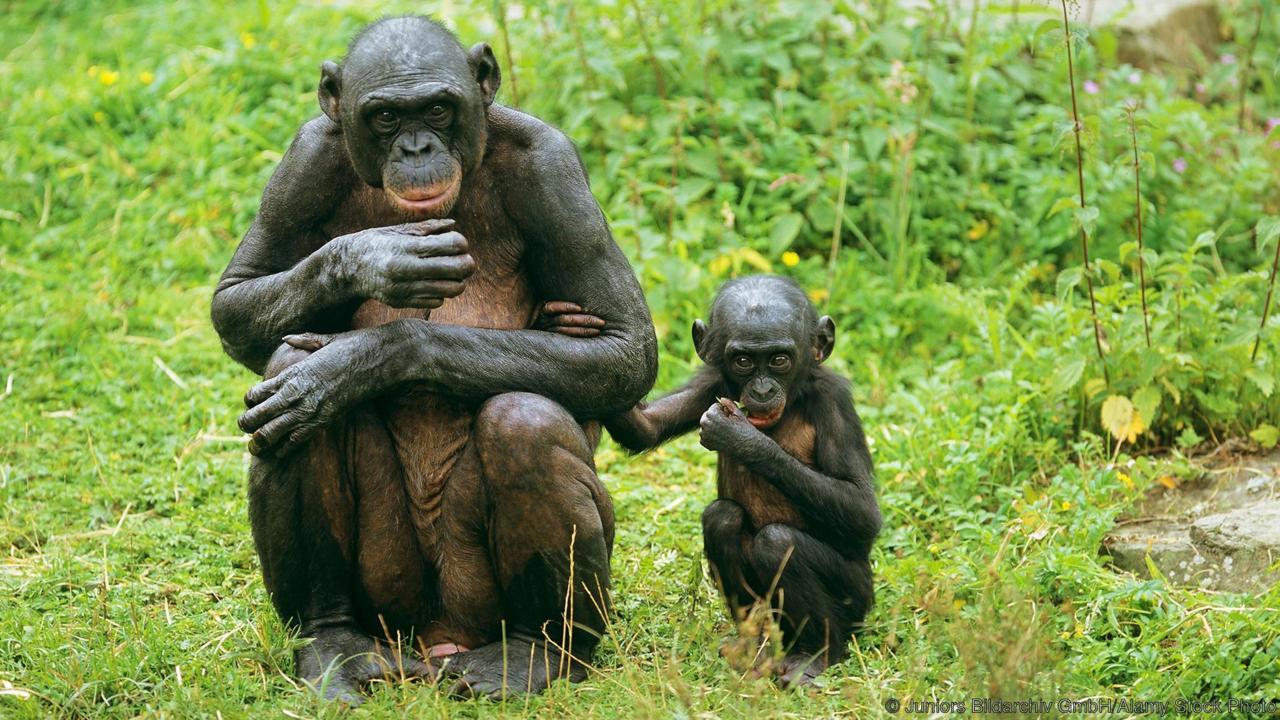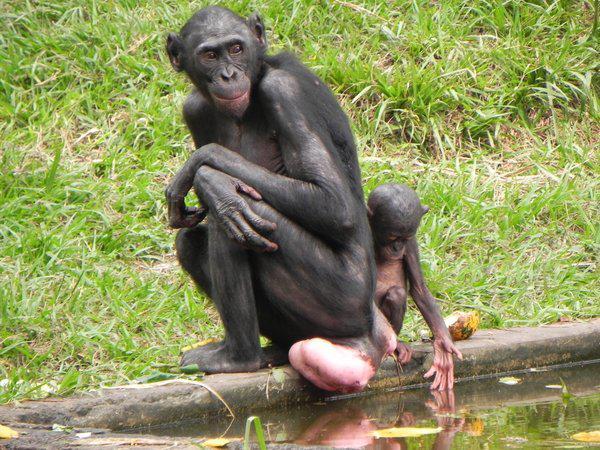The first image is the image on the left, the second image is the image on the right. Evaluate the accuracy of this statement regarding the images: "The baby monkey is staying close by the adult monkey.". Is it true? Answer yes or no. Yes. The first image is the image on the left, the second image is the image on the right. Given the left and right images, does the statement "The left image contains at least three chimpanzees." hold true? Answer yes or no. No. 